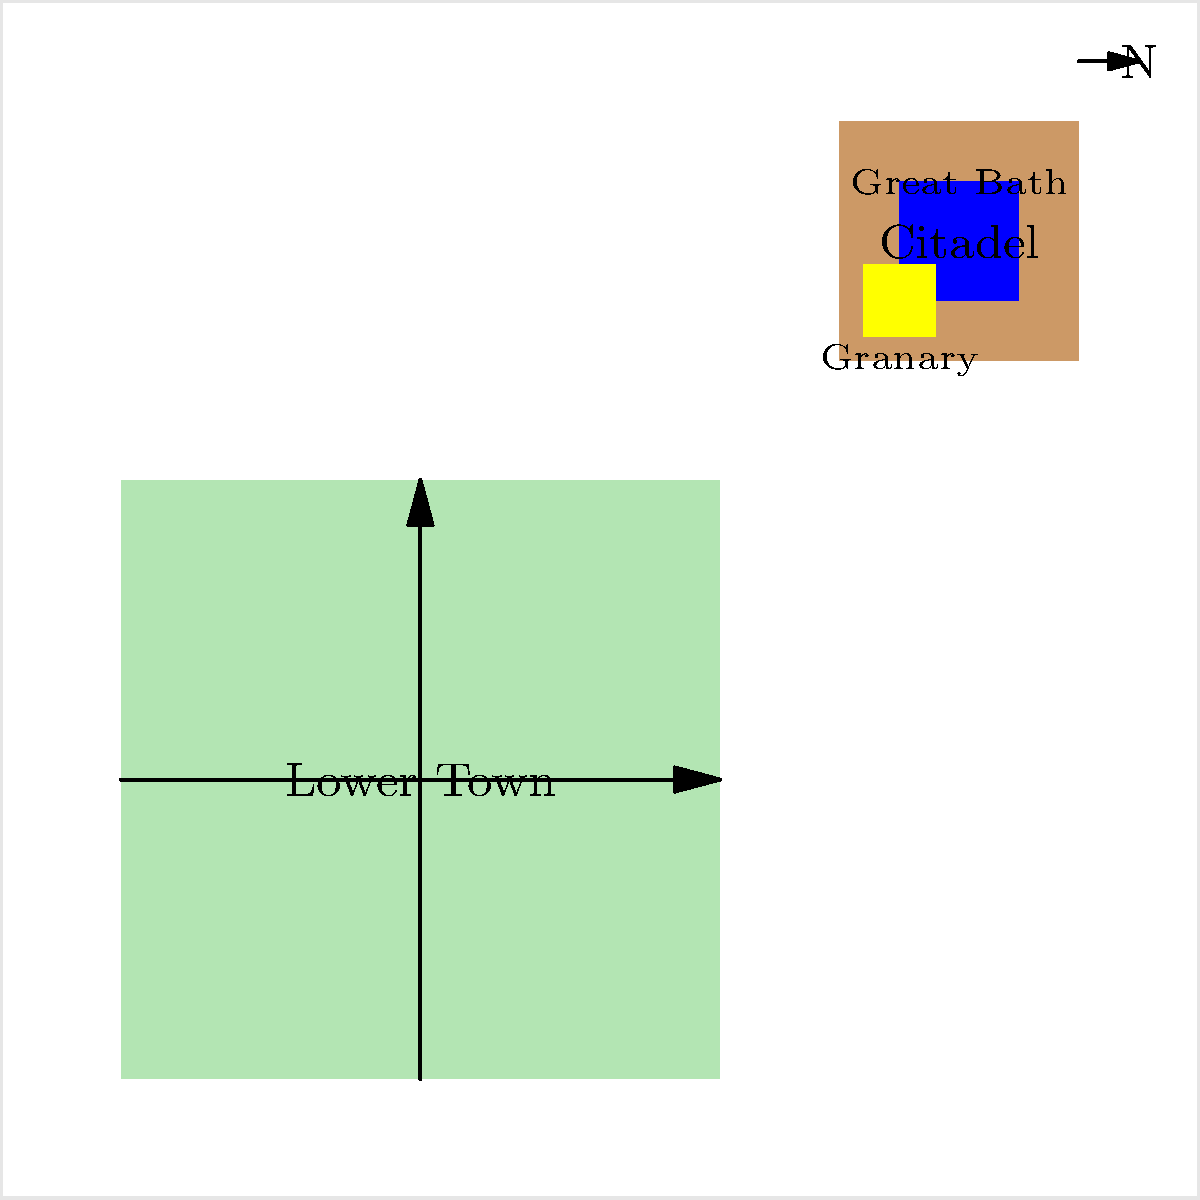Based on the architectural layout of Mohenjo-daro shown in the diagram, which structure is located in the northwestern part of the Citadel, and what was its likely purpose in Harappan society? To answer this question, let's break down the layout of Mohenjo-daro as shown in the diagram:

1. The city is divided into two main parts: the Citadel (upper right) and the Lower Town (lower left).

2. The Citadel is located in the northeastern part of the city, elevated and separated from the Lower Town.

3. Within the Citadel, we can see two prominent structures:
   a) A blue rectangle labeled "Great Bath"
   b) A yellow rectangle labeled "Granary"

4. The Granary is located in the northwestern part of the Citadel.

5. The purpose of the Granary in Harappan society:
   - It was used for storing and distributing grain, which was a crucial resource.
   - The presence of a large, centralized granary suggests a well-organized administrative system.
   - It implies that the society had agricultural surplus and a system of food redistribution.
   - The granary's location in the Citadel indicates its importance and the need for protection.

6. The Granary's significance:
   - It reflects the advanced urban planning of the Harappan civilization.
   - It suggests a complex socio-economic structure with centralized control over food resources.
   - The structure provides insight into the agricultural practices and trade systems of the Indus Valley Civilization.

Therefore, the structure located in the northwestern part of the Citadel is the Granary, and its purpose was likely for centralized grain storage and distribution, indicating a sophisticated administrative system in Harappan society.
Answer: Granary; centralized grain storage and distribution 